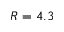<formula> <loc_0><loc_0><loc_500><loc_500>R = 4 . 3</formula> 